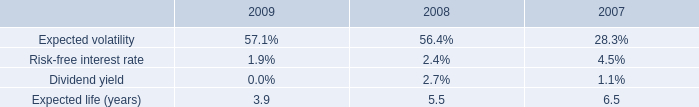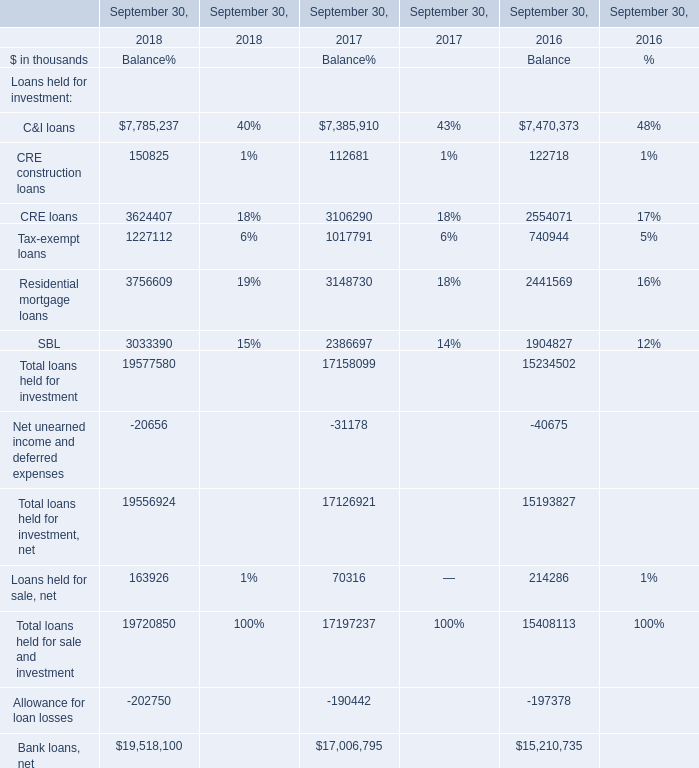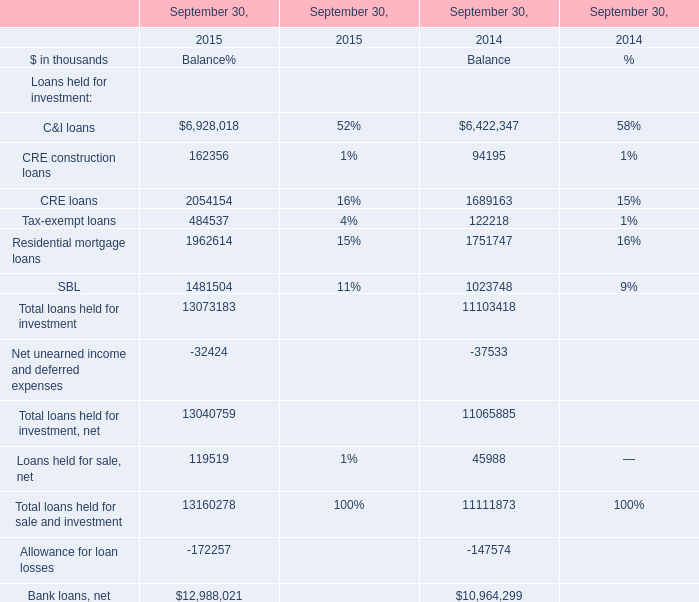what is the percent change in weighted-average estimated fair value of employee stock options between 2007 and 2008? 
Computations: ((3.47 - 5.95) / 5.95)
Answer: -0.41681. 